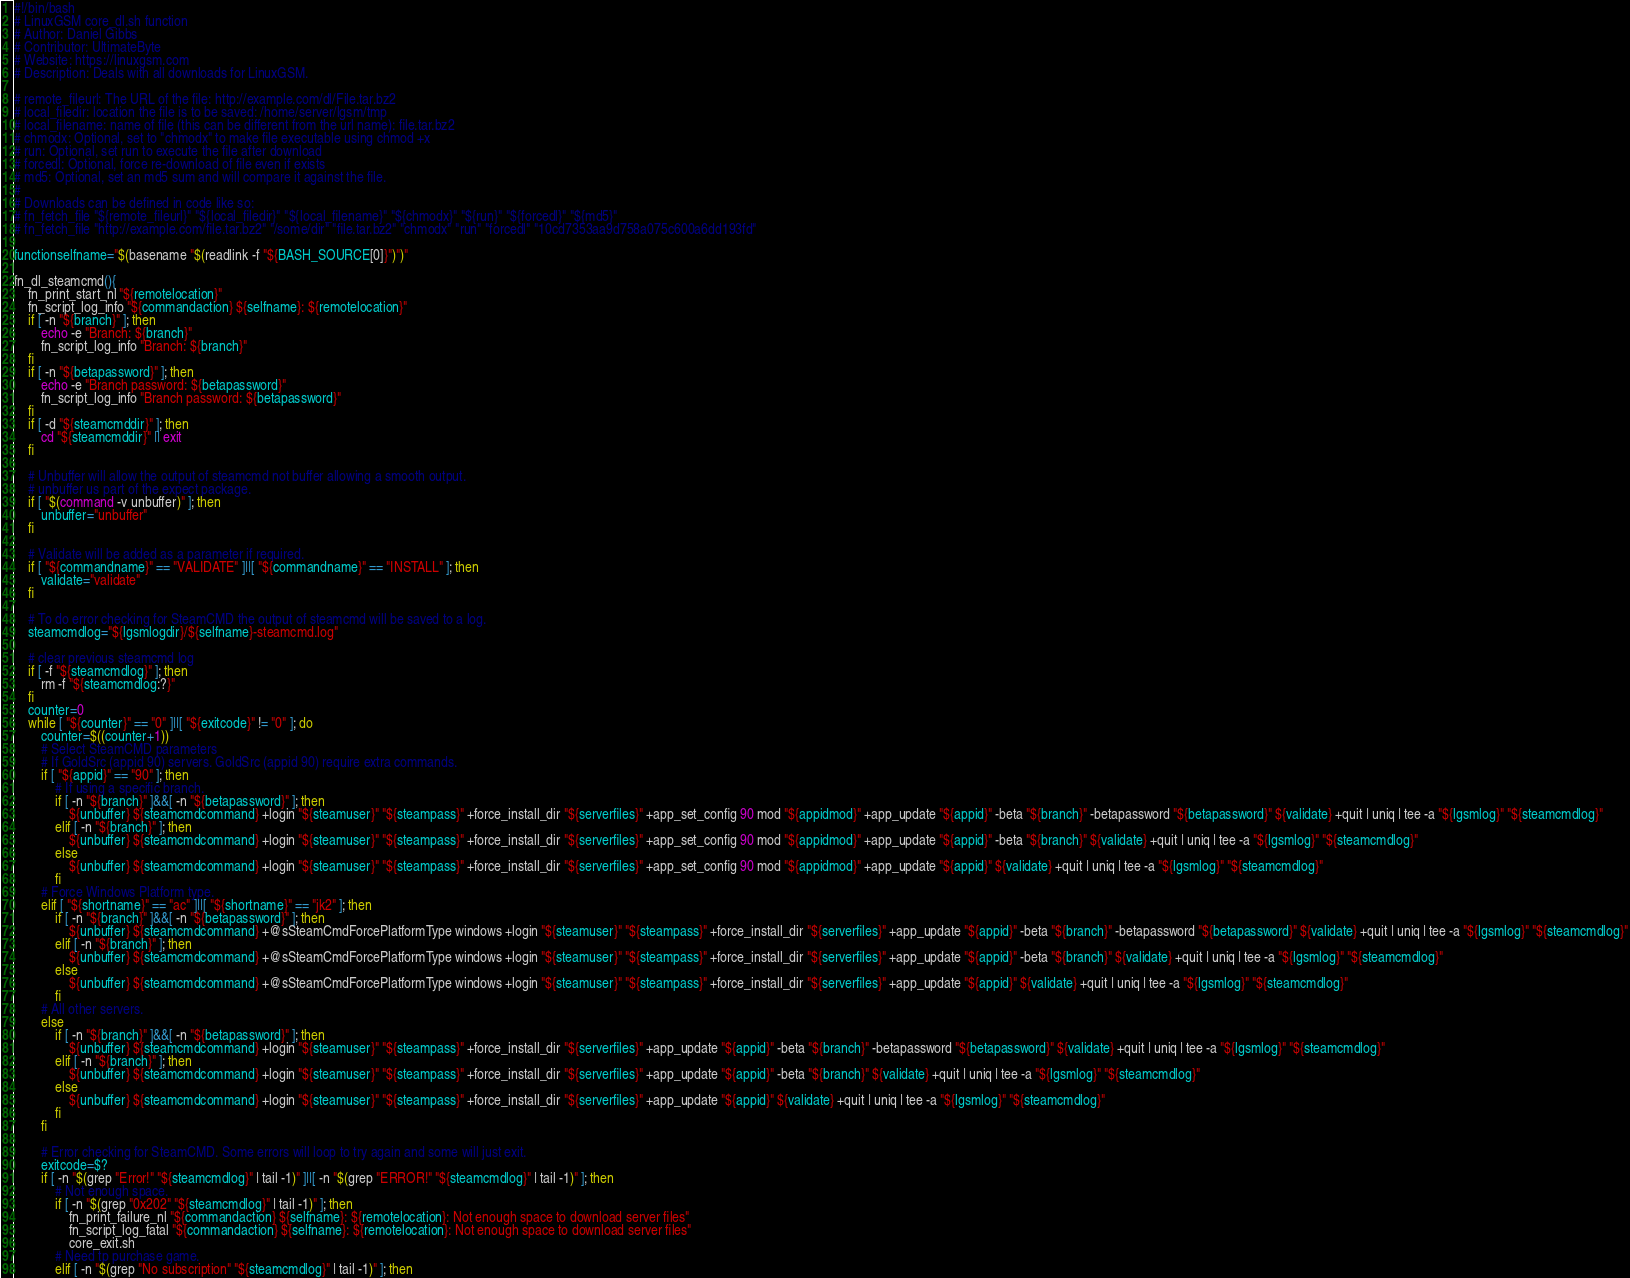Convert code to text. <code><loc_0><loc_0><loc_500><loc_500><_Bash_>#!/bin/bash
# LinuxGSM core_dl.sh function
# Author: Daniel Gibbs
# Contributor: UltimateByte
# Website: https://linuxgsm.com
# Description: Deals with all downloads for LinuxGSM.

# remote_fileurl: The URL of the file: http://example.com/dl/File.tar.bz2
# local_filedir: location the file is to be saved: /home/server/lgsm/tmp
# local_filename: name of file (this can be different from the url name): file.tar.bz2
# chmodx: Optional, set to "chmodx" to make file executable using chmod +x
# run: Optional, set run to execute the file after download
# forcedl: Optional, force re-download of file even if exists
# md5: Optional, set an md5 sum and will compare it against the file.
#
# Downloads can be defined in code like so:
# fn_fetch_file "${remote_fileurl}" "${local_filedir}" "${local_filename}" "${chmodx}" "${run}" "${forcedl}" "${md5}"
# fn_fetch_file "http://example.com/file.tar.bz2" "/some/dir" "file.tar.bz2" "chmodx" "run" "forcedl" "10cd7353aa9d758a075c600a6dd193fd"

functionselfname="$(basename "$(readlink -f "${BASH_SOURCE[0]}")")"

fn_dl_steamcmd(){
	fn_print_start_nl "${remotelocation}"
	fn_script_log_info "${commandaction} ${selfname}: ${remotelocation}"
	if [ -n "${branch}" ]; then
		echo -e "Branch: ${branch}"
		fn_script_log_info "Branch: ${branch}"
	fi
	if [ -n "${betapassword}" ]; then
		echo -e "Branch password: ${betapassword}"
		fn_script_log_info "Branch password: ${betapassword}"
	fi
	if [ -d "${steamcmddir}" ]; then
		cd "${steamcmddir}" || exit
	fi

	# Unbuffer will allow the output of steamcmd not buffer allowing a smooth output.
	# unbuffer us part of the expect package.
	if [ "$(command -v unbuffer)" ]; then
		unbuffer="unbuffer"
	fi

	# Validate will be added as a parameter if required.
	if [ "${commandname}" == "VALIDATE" ]||[ "${commandname}" == "INSTALL" ]; then
		validate="validate"
	fi

	# To do error checking for SteamCMD the output of steamcmd will be saved to a log.
	steamcmdlog="${lgsmlogdir}/${selfname}-steamcmd.log"

	# clear previous steamcmd log
	if [ -f "${steamcmdlog}" ]; then
		rm -f "${steamcmdlog:?}"
	fi
	counter=0
	while [ "${counter}" == "0" ]||[ "${exitcode}" != "0" ]; do
		counter=$((counter+1))
		# Select SteamCMD parameters
		# If GoldSrc (appid 90) servers. GoldSrc (appid 90) require extra commands.
		if [ "${appid}" == "90" ]; then
			# If using a specific branch.
			if [ -n "${branch}" ]&&[ -n "${betapassword}" ]; then
				${unbuffer} ${steamcmdcommand} +login "${steamuser}" "${steampass}" +force_install_dir "${serverfiles}" +app_set_config 90 mod "${appidmod}" +app_update "${appid}" -beta "${branch}" -betapassword "${betapassword}" ${validate} +quit | uniq | tee -a "${lgsmlog}" "${steamcmdlog}"
			elif [ -n "${branch}" ]; then
				${unbuffer} ${steamcmdcommand} +login "${steamuser}" "${steampass}" +force_install_dir "${serverfiles}" +app_set_config 90 mod "${appidmod}" +app_update "${appid}" -beta "${branch}" ${validate} +quit | uniq | tee -a "${lgsmlog}" "${steamcmdlog}"
			else
				${unbuffer} ${steamcmdcommand} +login "${steamuser}" "${steampass}" +force_install_dir "${serverfiles}" +app_set_config 90 mod "${appidmod}" +app_update "${appid}" ${validate} +quit | uniq | tee -a "${lgsmlog}" "${steamcmdlog}"
			fi
		# Force Windows Platform type.
		elif [ "${shortname}" == "ac" ]||[ "${shortname}" == "jk2" ]; then
			if [ -n "${branch}" ]&&[ -n "${betapassword}" ]; then
				${unbuffer} ${steamcmdcommand} +@sSteamCmdForcePlatformType windows +login "${steamuser}" "${steampass}" +force_install_dir "${serverfiles}" +app_update "${appid}" -beta "${branch}" -betapassword "${betapassword}" ${validate} +quit | uniq | tee -a "${lgsmlog}" "${steamcmdlog}"
			elif [ -n "${branch}" ]; then
				${unbuffer} ${steamcmdcommand} +@sSteamCmdForcePlatformType windows +login "${steamuser}" "${steampass}" +force_install_dir "${serverfiles}" +app_update "${appid}" -beta "${branch}" ${validate} +quit | uniq | tee -a "${lgsmlog}" "${steamcmdlog}"
			else
				${unbuffer} ${steamcmdcommand} +@sSteamCmdForcePlatformType windows +login "${steamuser}" "${steampass}" +force_install_dir "${serverfiles}" +app_update "${appid}" ${validate} +quit | uniq | tee -a "${lgsmlog}" "${steamcmdlog}"
			fi
		# All other servers.
		else
			if [ -n "${branch}" ]&&[ -n "${betapassword}" ]; then
				${unbuffer} ${steamcmdcommand} +login "${steamuser}" "${steampass}" +force_install_dir "${serverfiles}" +app_update "${appid}" -beta "${branch}" -betapassword "${betapassword}" ${validate} +quit | uniq | tee -a "${lgsmlog}" "${steamcmdlog}"
			elif [ -n "${branch}" ]; then
				${unbuffer} ${steamcmdcommand} +login "${steamuser}" "${steampass}" +force_install_dir "${serverfiles}" +app_update "${appid}" -beta "${branch}" ${validate} +quit | uniq | tee -a "${lgsmlog}" "${steamcmdlog}"
			else
				${unbuffer} ${steamcmdcommand} +login "${steamuser}" "${steampass}" +force_install_dir "${serverfiles}" +app_update "${appid}" ${validate} +quit | uniq | tee -a "${lgsmlog}" "${steamcmdlog}"
			fi
		fi

		# Error checking for SteamCMD. Some errors will loop to try again and some will just exit.
		exitcode=$?
		if [ -n "$(grep "Error!" "${steamcmdlog}" | tail -1)" ]||[ -n "$(grep "ERROR!" "${steamcmdlog}" | tail -1)" ]; then
			# Not enough space.
			if [ -n "$(grep "0x202" "${steamcmdlog}" | tail -1)" ]; then
				fn_print_failure_nl "${commandaction} ${selfname}: ${remotelocation}: Not enough space to download server files"
				fn_script_log_fatal "${commandaction} ${selfname}: ${remotelocation}: Not enough space to download server files"
				core_exit.sh
			# Need tp purchase game.
			elif [ -n "$(grep "No subscription" "${steamcmdlog}" | tail -1)" ]; then</code> 